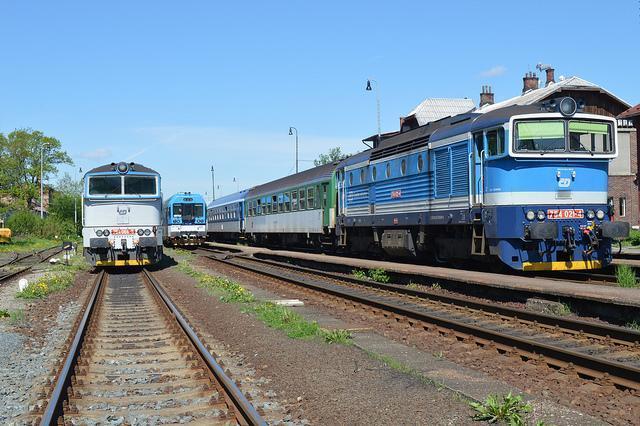How many trains are there?
Give a very brief answer. 3. How many tracks are seen?
Give a very brief answer. 3. How many trains are visible?
Give a very brief answer. 3. 